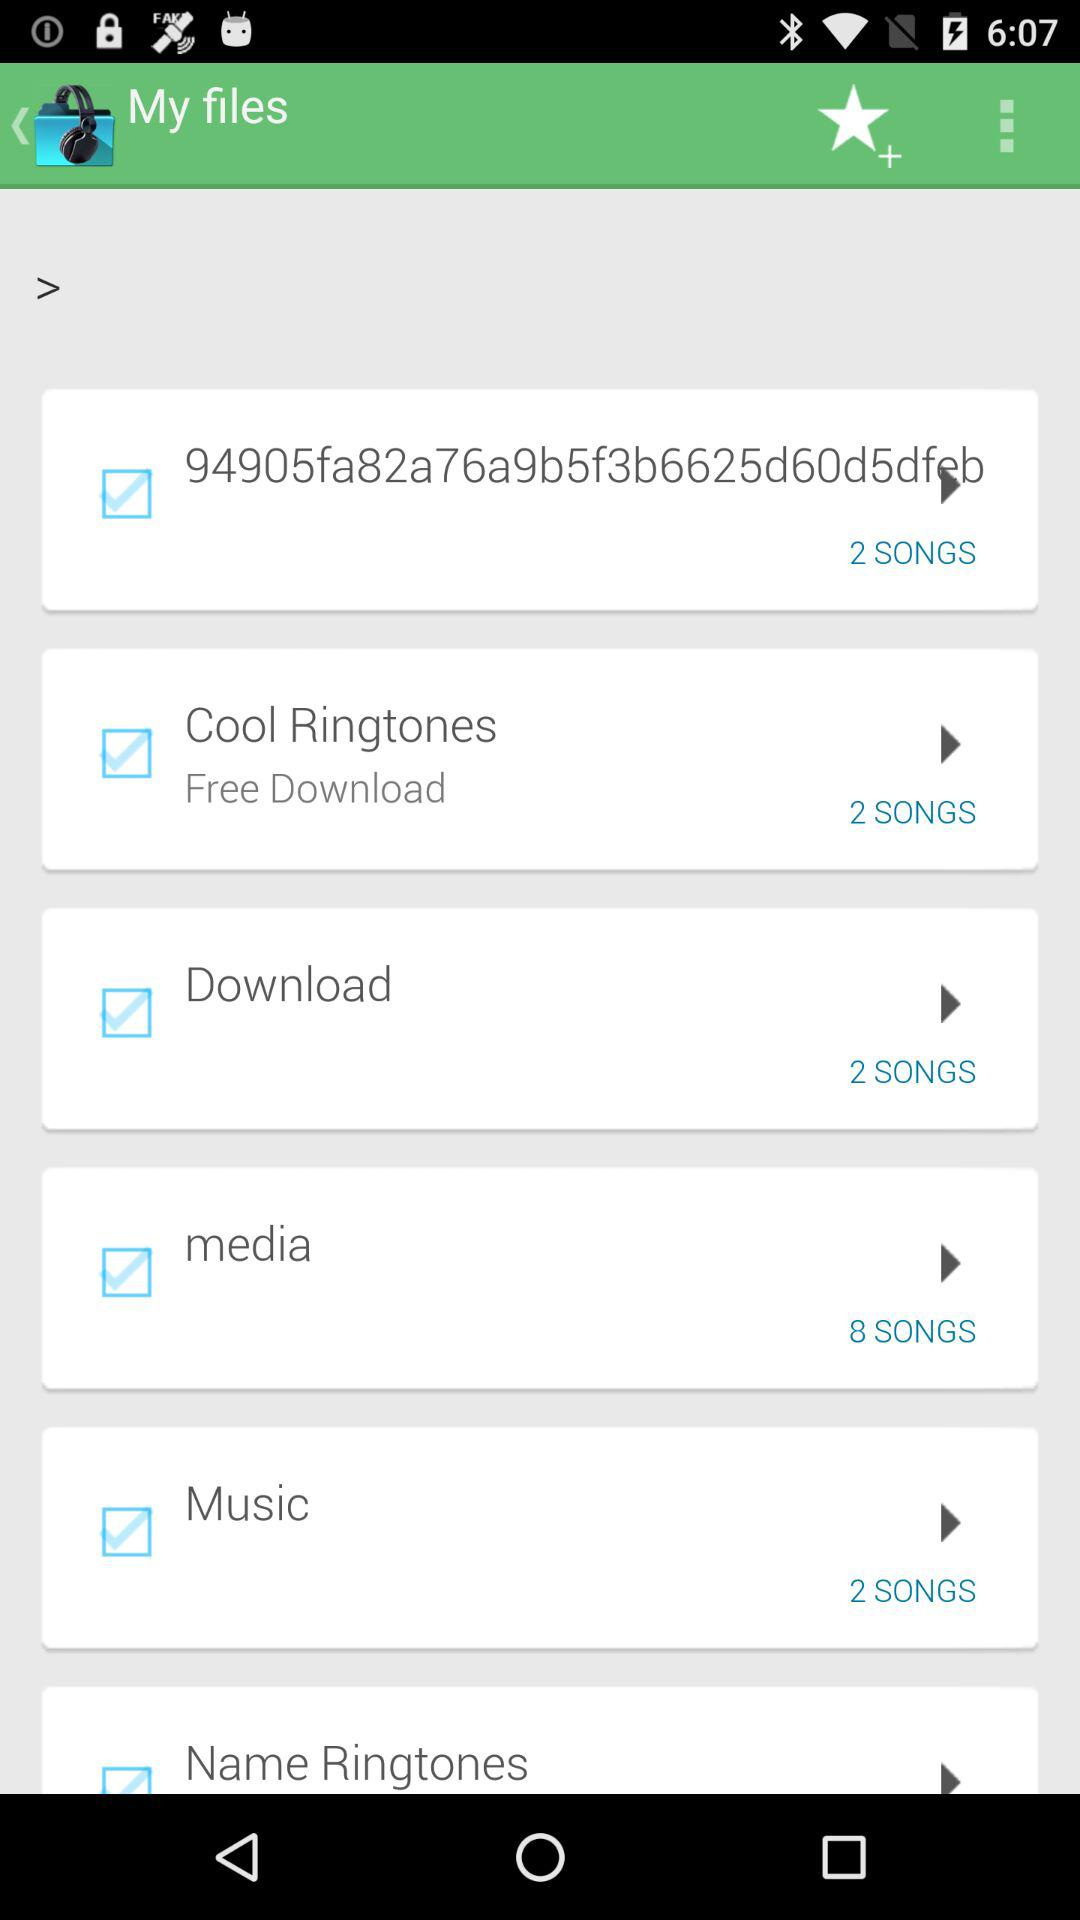How many songs are there in the "Music" folder? There are 2 songs in the "Music" folder. 